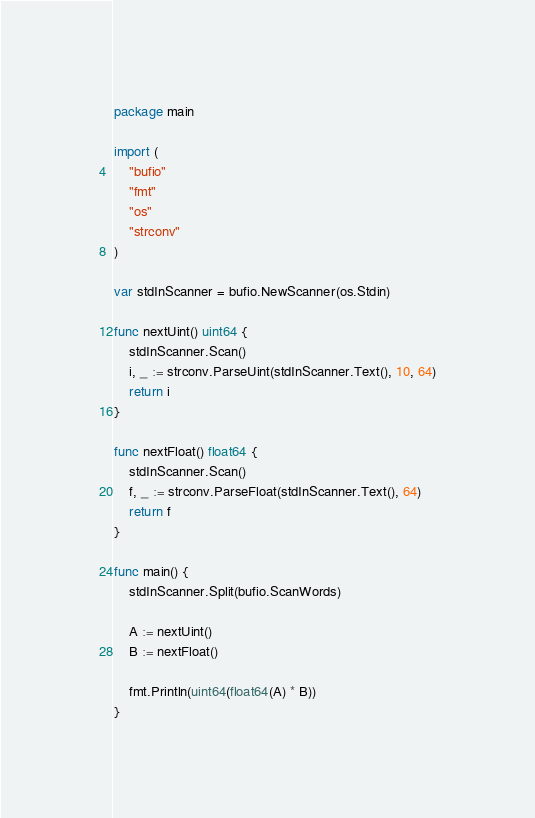Convert code to text. <code><loc_0><loc_0><loc_500><loc_500><_Go_>package main

import (
	"bufio"
	"fmt"
	"os"
	"strconv"
)

var stdInScanner = bufio.NewScanner(os.Stdin)

func nextUint() uint64 {
	stdInScanner.Scan()
	i, _ := strconv.ParseUint(stdInScanner.Text(), 10, 64)
	return i
}

func nextFloat() float64 {
	stdInScanner.Scan()
	f, _ := strconv.ParseFloat(stdInScanner.Text(), 64)
	return f
}

func main() {
	stdInScanner.Split(bufio.ScanWords)

	A := nextUint()
	B := nextFloat()

	fmt.Println(uint64(float64(A) * B))
}
</code> 